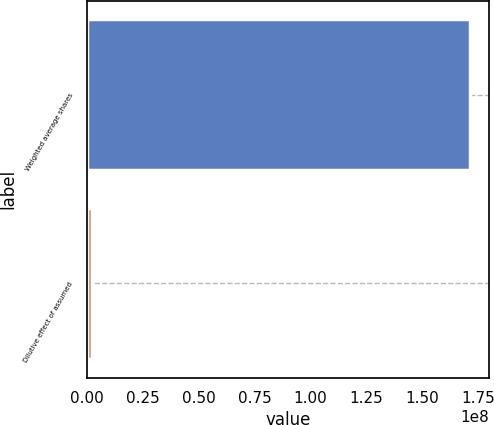<chart> <loc_0><loc_0><loc_500><loc_500><bar_chart><fcel>Weighted average shares<fcel>Dilutive effect of assumed<nl><fcel>1.71254e+08<fcel>2.059e+06<nl></chart> 